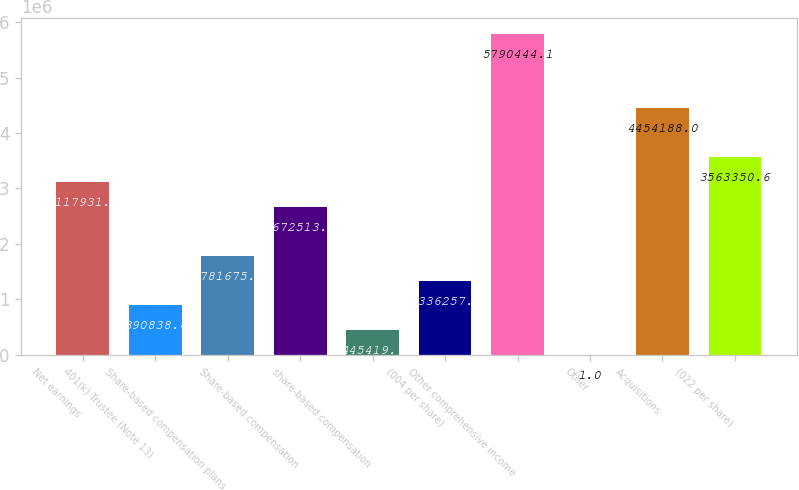Convert chart. <chart><loc_0><loc_0><loc_500><loc_500><bar_chart><fcel>Net earnings<fcel>401(k) Trustee (Note 13)<fcel>Share-based compensation plans<fcel>Share-based compensation<fcel>share-based compensation<fcel>(004 per share)<fcel>Other comprehensive income<fcel>Other<fcel>Acquisitions<fcel>(022 per share)<nl><fcel>3.11793e+06<fcel>890838<fcel>1.78168e+06<fcel>2.67251e+06<fcel>445420<fcel>1.33626e+06<fcel>5.79044e+06<fcel>1<fcel>4.45419e+06<fcel>3.56335e+06<nl></chart> 